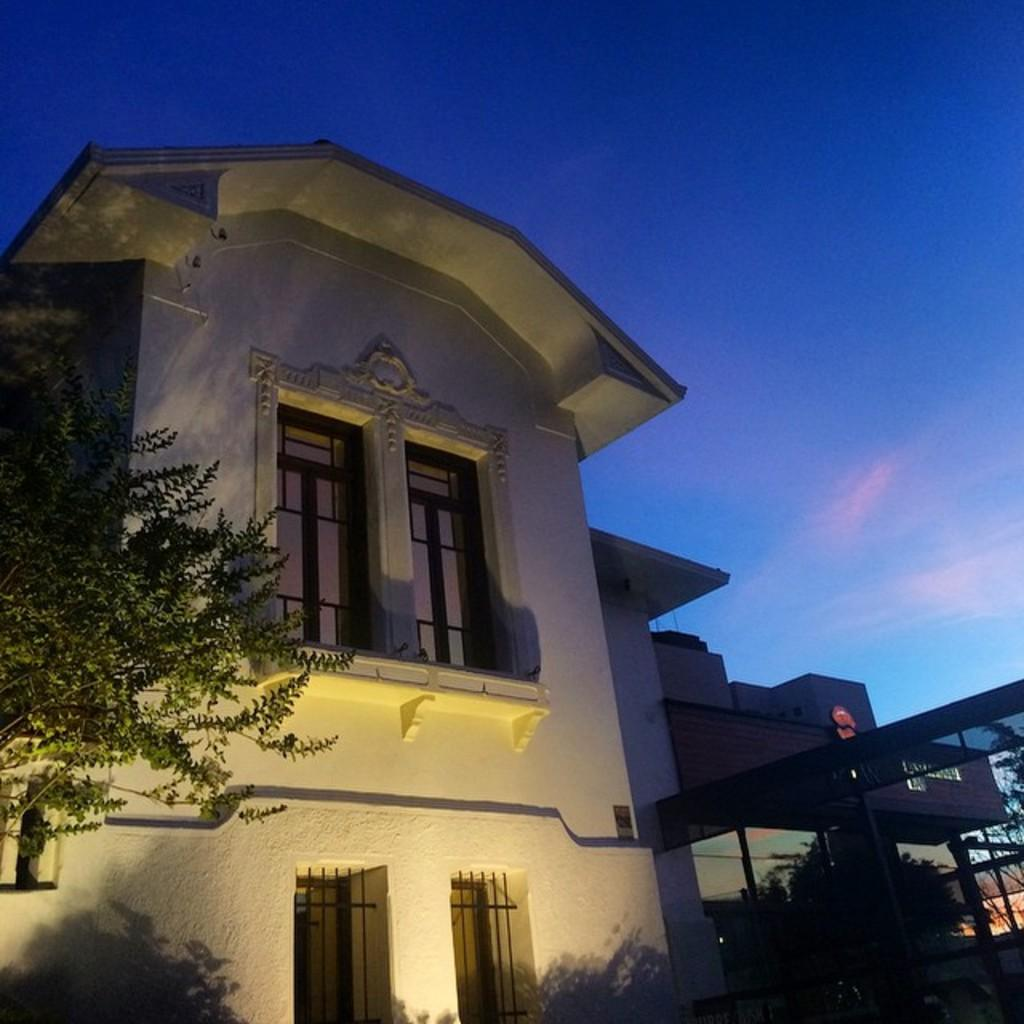What type of structures can be seen in the image? There are buildings in the image. What is present on either side of the buildings? There are trees on either side of the buildings. What color is the sky in the image? The sky is blue in color. What type of plantation can be seen in the image? There is no plantation present in the image; it features buildings with trees on either side and a blue sky. What type of lace can be seen on the buildings in the image? There is no lace present on the buildings in the image. 